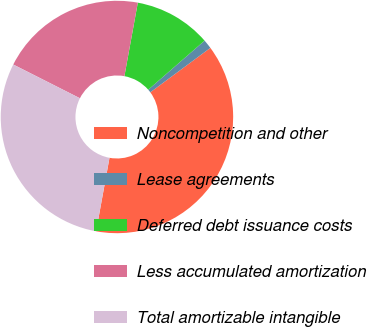Convert chart. <chart><loc_0><loc_0><loc_500><loc_500><pie_chart><fcel>Noncompetition and other<fcel>Lease agreements<fcel>Deferred debt issuance costs<fcel>Less accumulated amortization<fcel>Total amortizable intangible<nl><fcel>38.01%<fcel>1.27%<fcel>10.72%<fcel>20.42%<fcel>29.58%<nl></chart> 